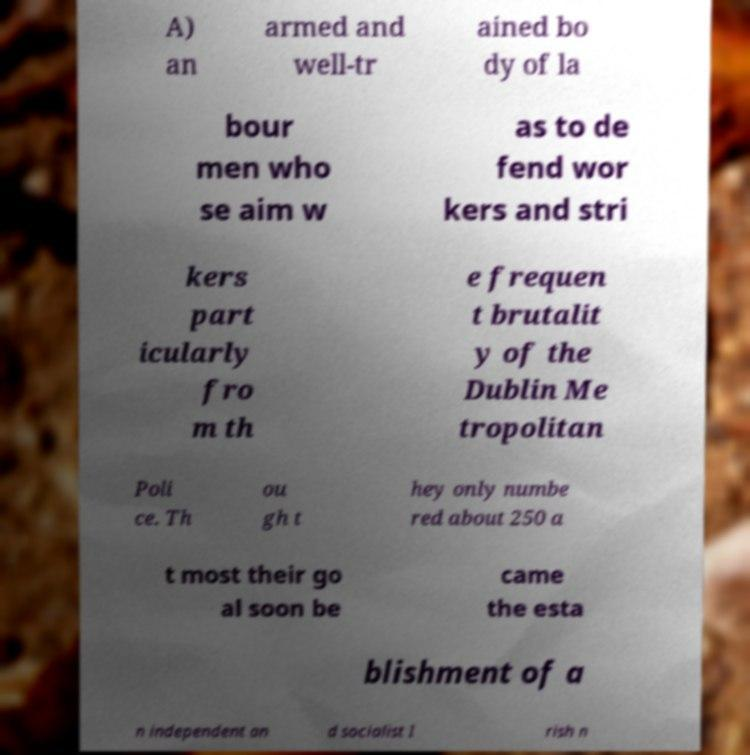For documentation purposes, I need the text within this image transcribed. Could you provide that? A) an armed and well-tr ained bo dy of la bour men who se aim w as to de fend wor kers and stri kers part icularly fro m th e frequen t brutalit y of the Dublin Me tropolitan Poli ce. Th ou gh t hey only numbe red about 250 a t most their go al soon be came the esta blishment of a n independent an d socialist I rish n 